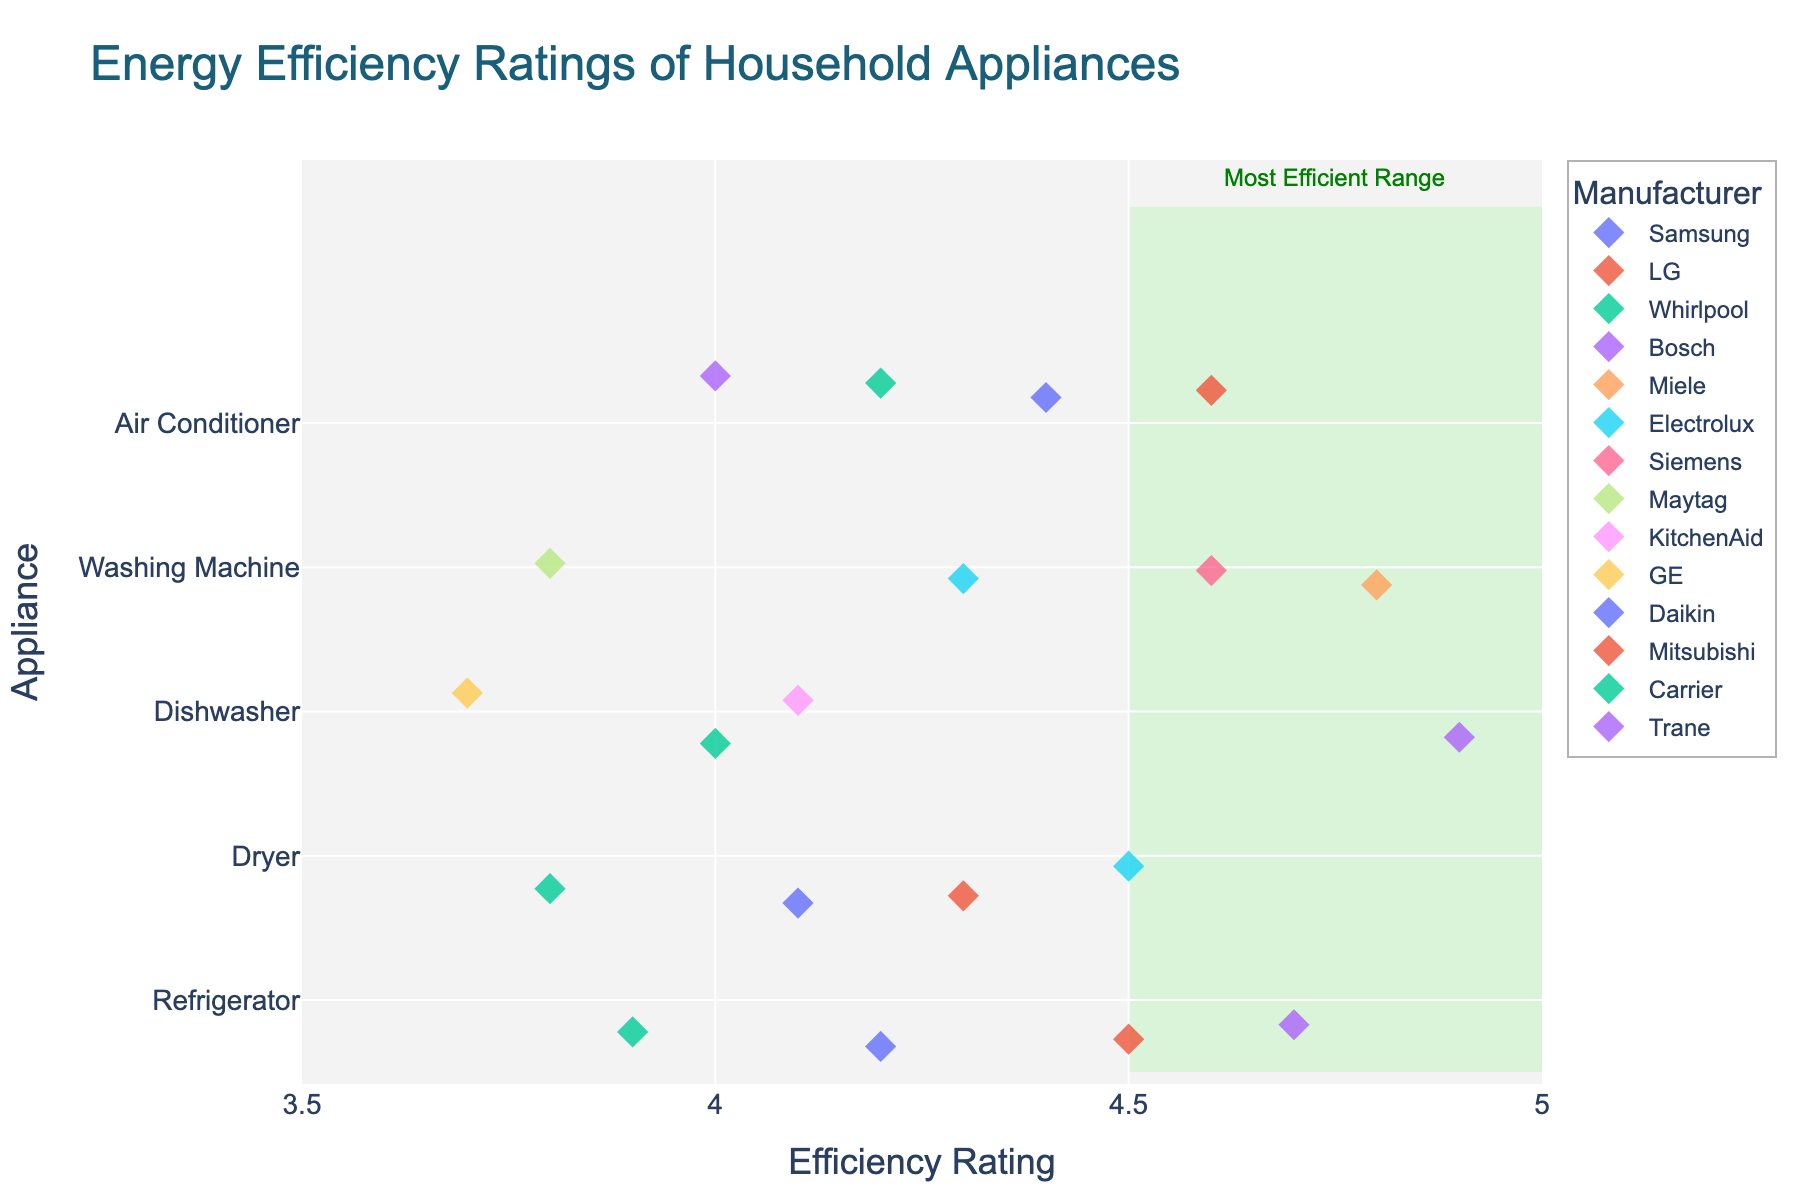What's the title of the plot? The title is usually displayed at the top of a plot, providing an overview of what the plot represents. Here, it is clearly stated in a large font.
Answer: Energy Efficiency Ratings of Household Appliances How many different types of appliances are displayed in the plot? By looking at the y-axis, each different appliance has its own label. Count the labels to determine the number of unique appliances.
Answer: 5 Which manufacturer has the highest energy efficiency rating for washing machines? First, locate the washing machines on the y-axis. Identify all points associated with washing machine ratings and look for the highest point. Check the color and legend to find the manufacturer.
Answer: Miele What's the range of the x-axis in the plot? The x-axis shows the range of energy efficiency ratings. This can be identified by looking at the numbers at both ends of the x-axis.
Answer: 3.5 to 5.0 Which appliance has the most data points in the 'Most Efficient Range'? The 'Most Efficient Range' is highlighted in green. Count the number of points in this range for each appliance on the y-axis.
Answer: Refrigerator What is the average energy efficiency rating for dishwashers? Locate all dishwashers on the y-axis and find their respective ratings on the x-axis. Sum these ratings and divide by the number of dishwashers to calculate the average.
Answer: (4.1 + 4.9 + 4.0 + 3.7) / 4 = 4.18 Which appliance has the lowest energy efficiency rating and what is it? Identify the point furthest to the left on the x-axis for each appliance type. Check the label on the y-axis to determine the appliance.
Answer: Dishwasher, 3.7 How does the energy efficiency rating of LG's refrigerators compare to Samsung's dryers? Find the data points for LG refrigerators and Samsung dryers on the y-axis. Compare their positions on the x-axis to see which is higher.
Answer: LG refrigerators are higher Are there any manufacturers with more than one appliance in the 'Most Efficient Range'? Look at the manufacturers' data points that fall within the green shaded area and count how many unique appliances each manufacturer has in that region.
Answer: Yes, Bosch 